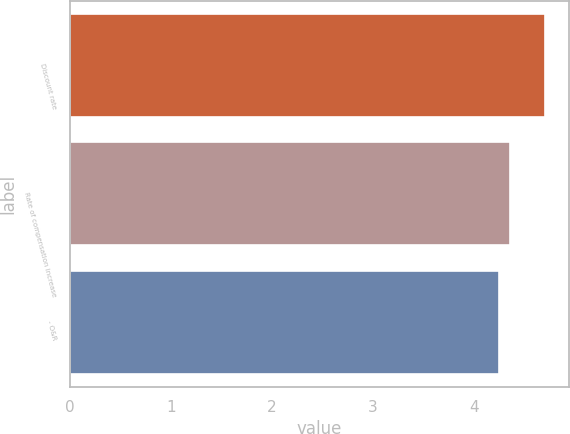<chart> <loc_0><loc_0><loc_500><loc_500><bar_chart><fcel>Discount rate<fcel>Rate of compensation increase<fcel>- O&R<nl><fcel>4.7<fcel>4.35<fcel>4.25<nl></chart> 